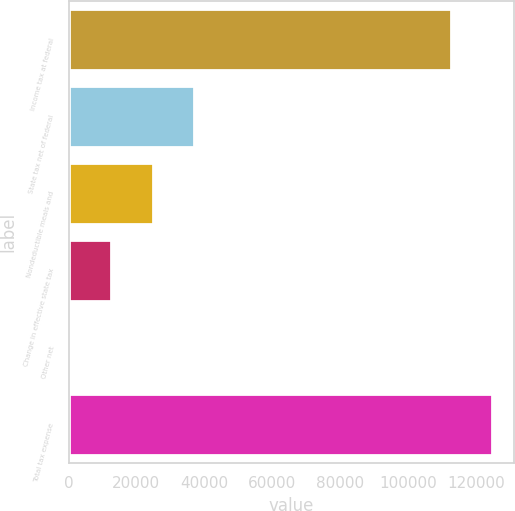Convert chart. <chart><loc_0><loc_0><loc_500><loc_500><bar_chart><fcel>Income tax at federal<fcel>State tax net of federal<fcel>Nondeductible meals and<fcel>Change in effective state tax<fcel>Other net<fcel>Total tax expense<nl><fcel>112782<fcel>36856.2<fcel>24743.8<fcel>12631.4<fcel>519<fcel>124894<nl></chart> 